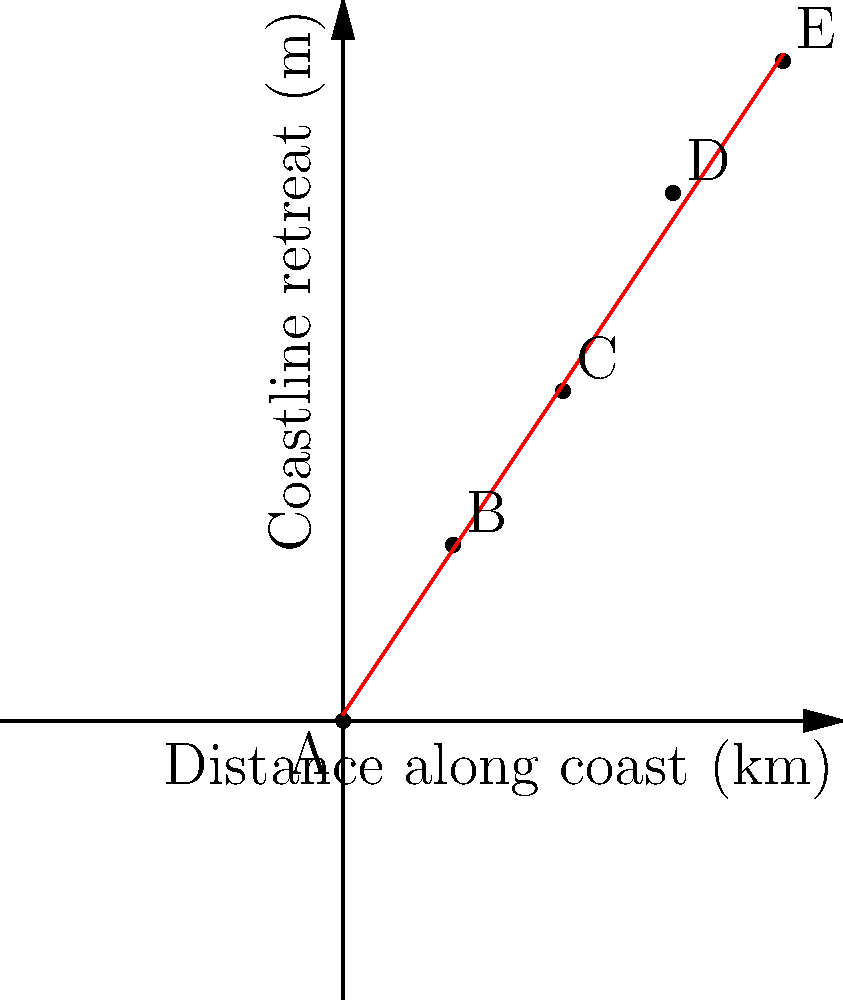As part of your coastal erosion study, you've collected data on coastline retreat over a 20 km stretch. The graph shows the retreat distance at 5 km intervals. Calculate the average rate of coastline erosion (in m/km) based on the trend line from point A to point E. To calculate the average rate of coastline erosion, we need to determine the slope of the trend line from point A to point E. This can be done using the slope formula:

$$ \text{Slope} = \frac{\text{Change in y}}{\text{Change in x}} = \frac{\Delta y}{\Delta x} $$

Step 1: Identify the coordinates of points A and E.
Point A: (0, 0)
Point E: (20, 30)

Step 2: Calculate the change in x (distance along coast) and y (coastline retreat).
$\Delta x = 20 - 0 = 20$ km
$\Delta y = 30 - 0 = 30$ m

Step 3: Apply the slope formula.
$$ \text{Slope} = \frac{\Delta y}{\Delta x} = \frac{30 \text{ m}}{20 \text{ km}} = 1.5 \text{ m/km} $$

The slope of 1.5 m/km represents the average rate of coastline erosion along this stretch of coast.
Answer: 1.5 m/km 